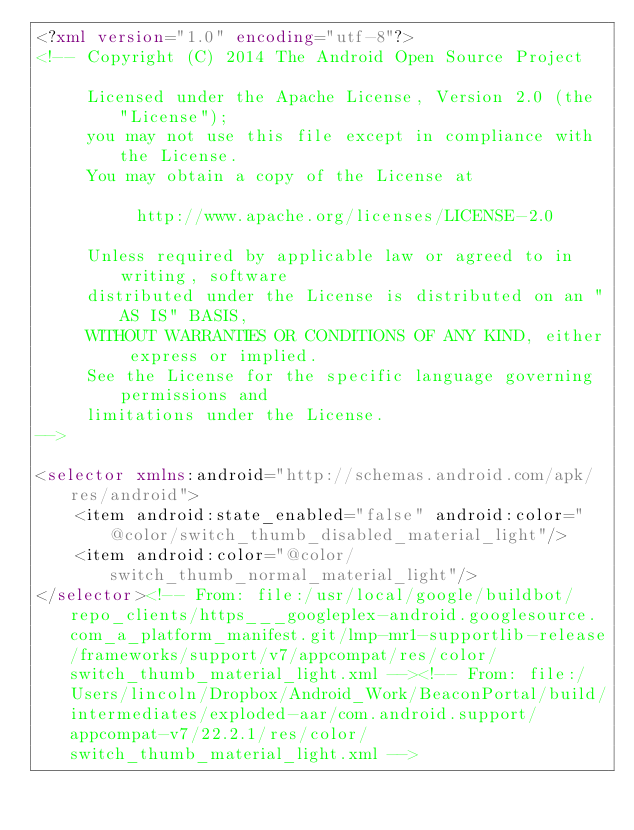Convert code to text. <code><loc_0><loc_0><loc_500><loc_500><_XML_><?xml version="1.0" encoding="utf-8"?>
<!-- Copyright (C) 2014 The Android Open Source Project

     Licensed under the Apache License, Version 2.0 (the "License");
     you may not use this file except in compliance with the License.
     You may obtain a copy of the License at

          http://www.apache.org/licenses/LICENSE-2.0

     Unless required by applicable law or agreed to in writing, software
     distributed under the License is distributed on an "AS IS" BASIS,
     WITHOUT WARRANTIES OR CONDITIONS OF ANY KIND, either express or implied.
     See the License for the specific language governing permissions and
     limitations under the License.
-->

<selector xmlns:android="http://schemas.android.com/apk/res/android">
    <item android:state_enabled="false" android:color="@color/switch_thumb_disabled_material_light"/>
    <item android:color="@color/switch_thumb_normal_material_light"/>
</selector><!-- From: file:/usr/local/google/buildbot/repo_clients/https___googleplex-android.googlesource.com_a_platform_manifest.git/lmp-mr1-supportlib-release/frameworks/support/v7/appcompat/res/color/switch_thumb_material_light.xml --><!-- From: file:/Users/lincoln/Dropbox/Android_Work/BeaconPortal/build/intermediates/exploded-aar/com.android.support/appcompat-v7/22.2.1/res/color/switch_thumb_material_light.xml --></code> 